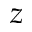Convert formula to latex. <formula><loc_0><loc_0><loc_500><loc_500>z</formula> 